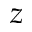Convert formula to latex. <formula><loc_0><loc_0><loc_500><loc_500>z</formula> 